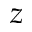Convert formula to latex. <formula><loc_0><loc_0><loc_500><loc_500>z</formula> 